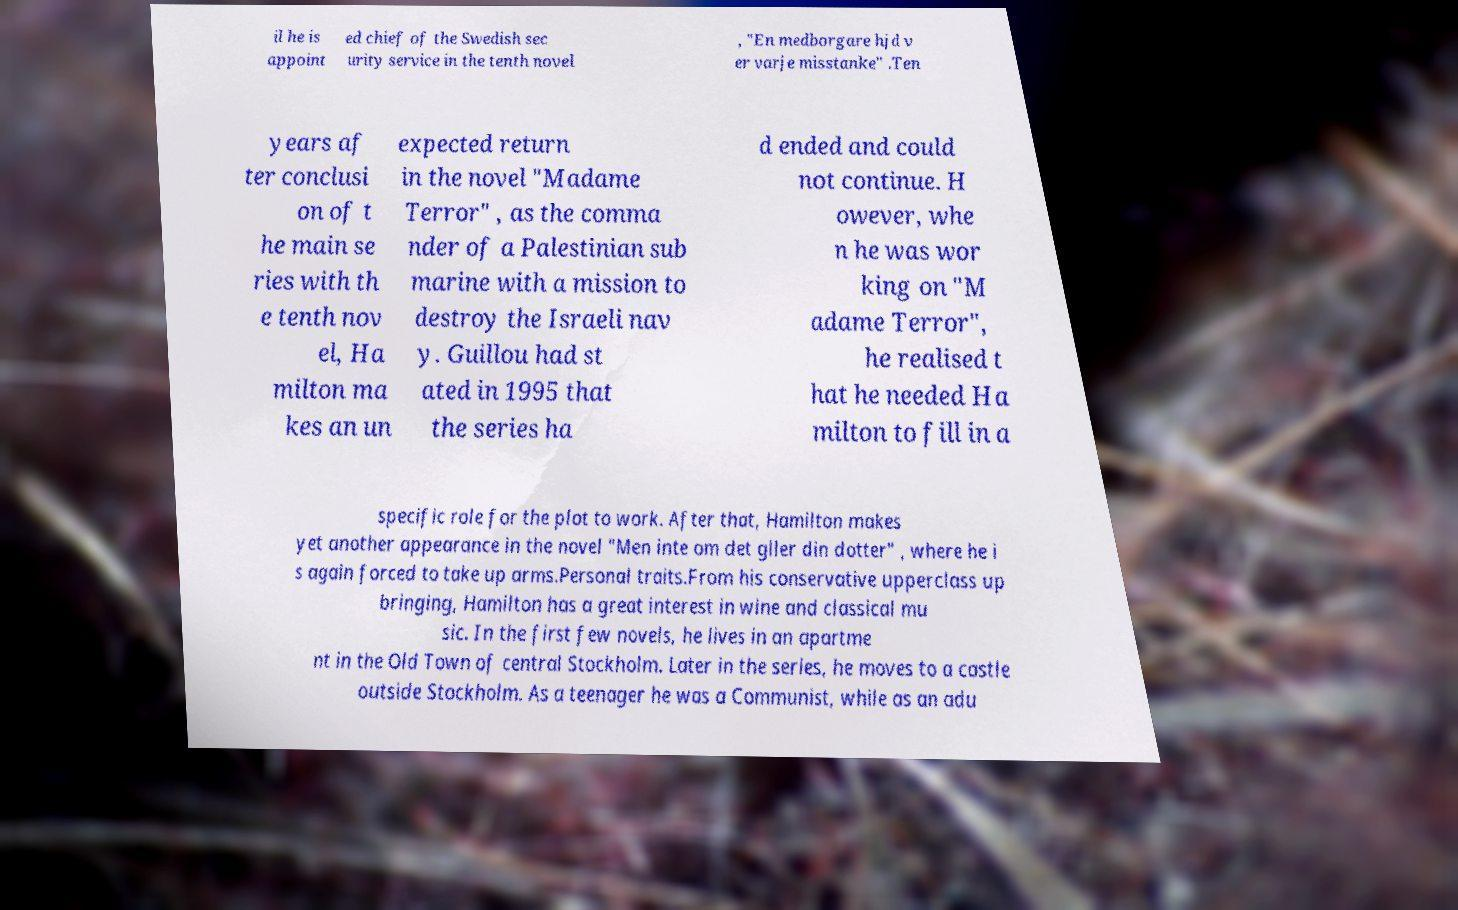Can you read and provide the text displayed in the image?This photo seems to have some interesting text. Can you extract and type it out for me? il he is appoint ed chief of the Swedish sec urity service in the tenth novel , "En medborgare hjd v er varje misstanke" .Ten years af ter conclusi on of t he main se ries with th e tenth nov el, Ha milton ma kes an un expected return in the novel "Madame Terror" , as the comma nder of a Palestinian sub marine with a mission to destroy the Israeli nav y. Guillou had st ated in 1995 that the series ha d ended and could not continue. H owever, whe n he was wor king on "M adame Terror", he realised t hat he needed Ha milton to fill in a specific role for the plot to work. After that, Hamilton makes yet another appearance in the novel "Men inte om det gller din dotter" , where he i s again forced to take up arms.Personal traits.From his conservative upperclass up bringing, Hamilton has a great interest in wine and classical mu sic. In the first few novels, he lives in an apartme nt in the Old Town of central Stockholm. Later in the series, he moves to a castle outside Stockholm. As a teenager he was a Communist, while as an adu 